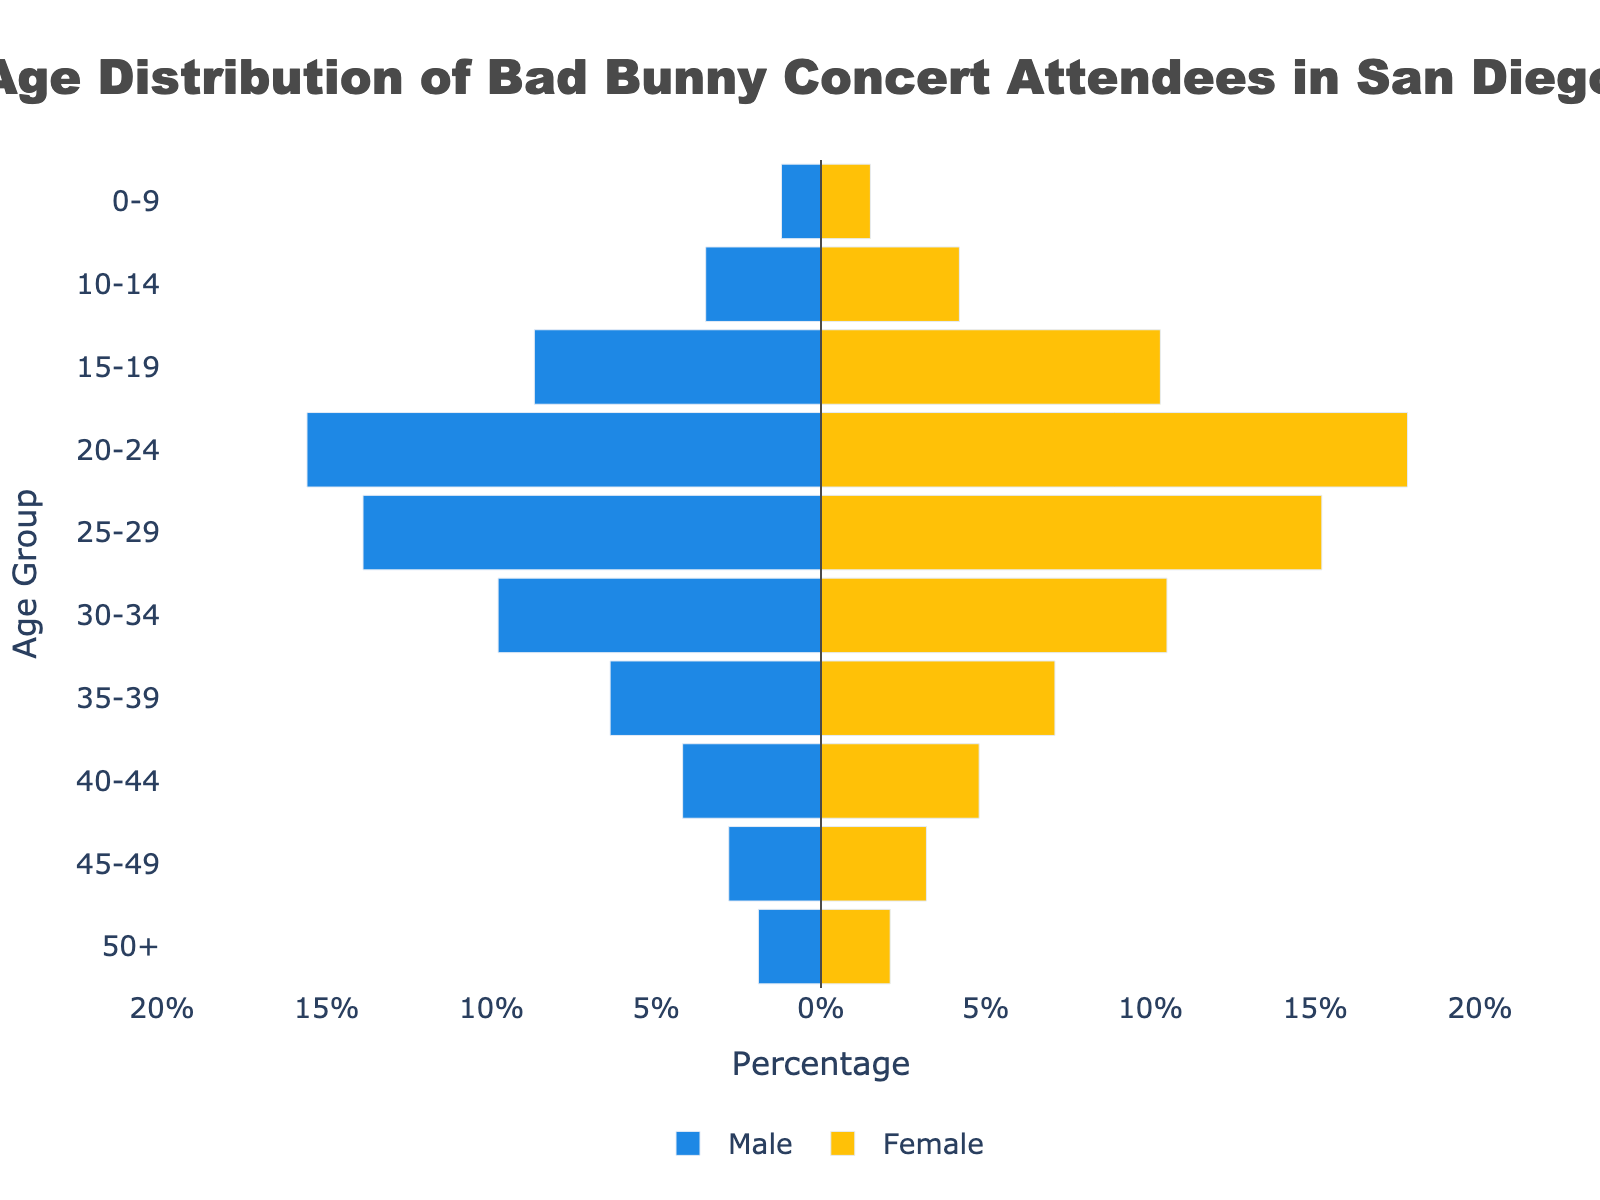What's the title of the figure? The title is clearly displayed at the top center of the figure.
Answer: Age Distribution of Bad Bunny Concert Attendees in San Diego What percentage of attendees in the age group 20-24 are male? The bar for males in the age group 20-24 extends to -15.6% as male values are on the negative side.
Answer: 15.6% How does the proportion of female attendees in the age group 15-19 compare to that in the age group 0-9? The length of the female bars shows that the age group 15-19 has 10.3% of attendees, whereas the age group 0-9 has 1.5%.
Answer: 15-19 group has 8.8% more females Which age group has the highest percentage of female attendees? Examining the lengths of the female bars will show that the age group 20-24 has the highest percentage at 17.8%.
Answer: 20-24 What is the difference in the percentage of male and female attendees in the age group 25-29? The female bar for 25-29 is 15.2%, and the male bar is -13.9%. The difference in percentage is calculated as 15.2 - 13.9 = 1.3%.
Answer: 1.3% In which age group is the gender distribution most equal? You can determine this by finding the age group where the bars for males and females are closest in length. For the age group 50+, the male value is 1.9% and the female value is 2.1%, giving the least difference of 0.2%.
Answer: 50+ What is the total percentage of concert attendees aged 30-34? Adding the male and female percentages in the group 30-34, we get 9.8% + 10.5% = 20.3%.
Answer: 20.3% Which age group has more male attendees compared to females? By looking at the negative and positive values for each age group, we see that no age group has more male attendees compared to females, since all female values are higher.
Answer: None What is the combined percentage of attendees under 15 years of age? Sum the percentages of both males and females for age groups 0-9 and 10-14: (1.2+1.5) + (3.5+4.2) = 2.7 + 7.7 = 10.4%.
Answer: 10.4% Which age group has the greatest discrepancy between male and female attendees? Calculate the differences for each age group and find the maximum. Age group 20-24 has the largest difference:
Answer: 2.2 